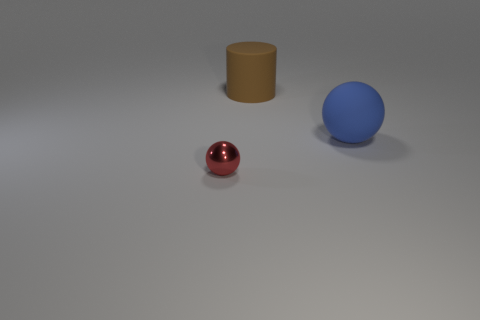Add 1 tiny brown objects. How many objects exist? 4 Subtract all balls. How many objects are left? 1 Subtract all large green matte things. Subtract all big matte objects. How many objects are left? 1 Add 3 large blue rubber objects. How many large blue rubber objects are left? 4 Add 1 red balls. How many red balls exist? 2 Subtract 0 green cylinders. How many objects are left? 3 